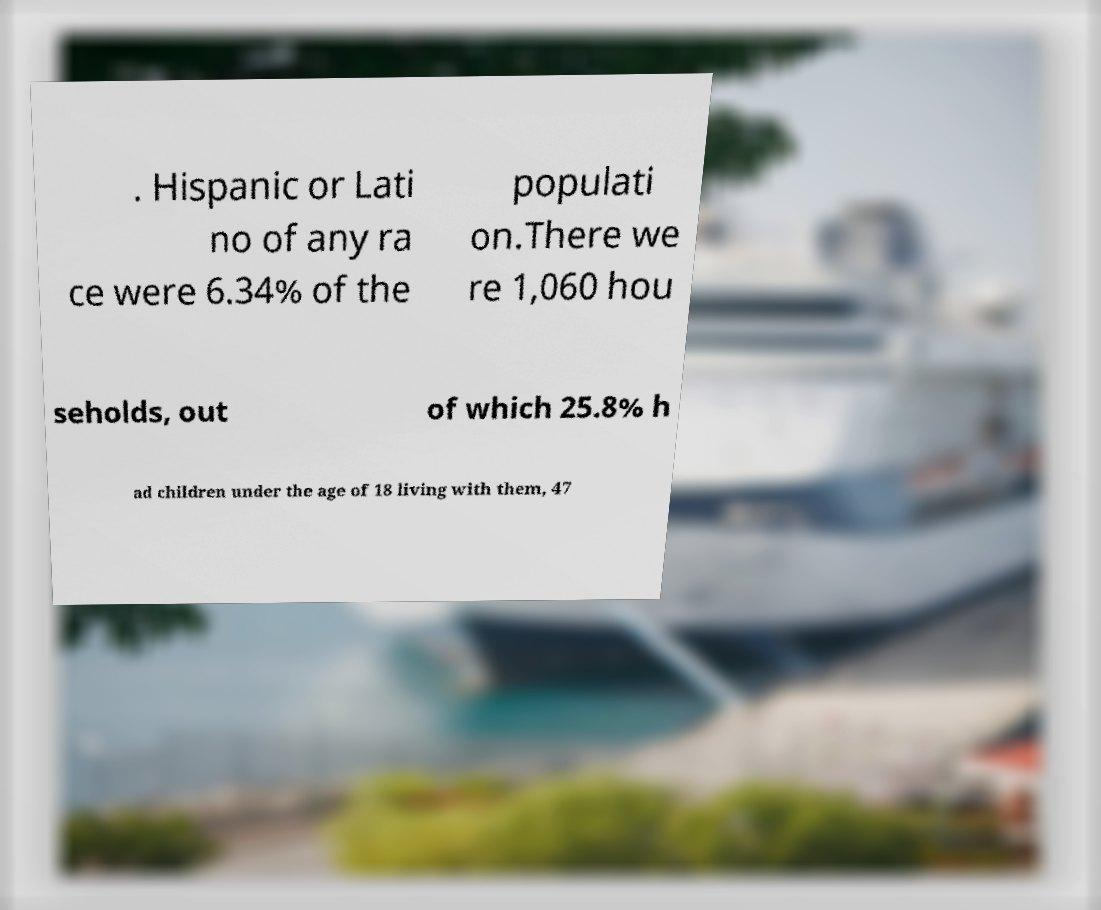Please read and relay the text visible in this image. What does it say? . Hispanic or Lati no of any ra ce were 6.34% of the populati on.There we re 1,060 hou seholds, out of which 25.8% h ad children under the age of 18 living with them, 47 